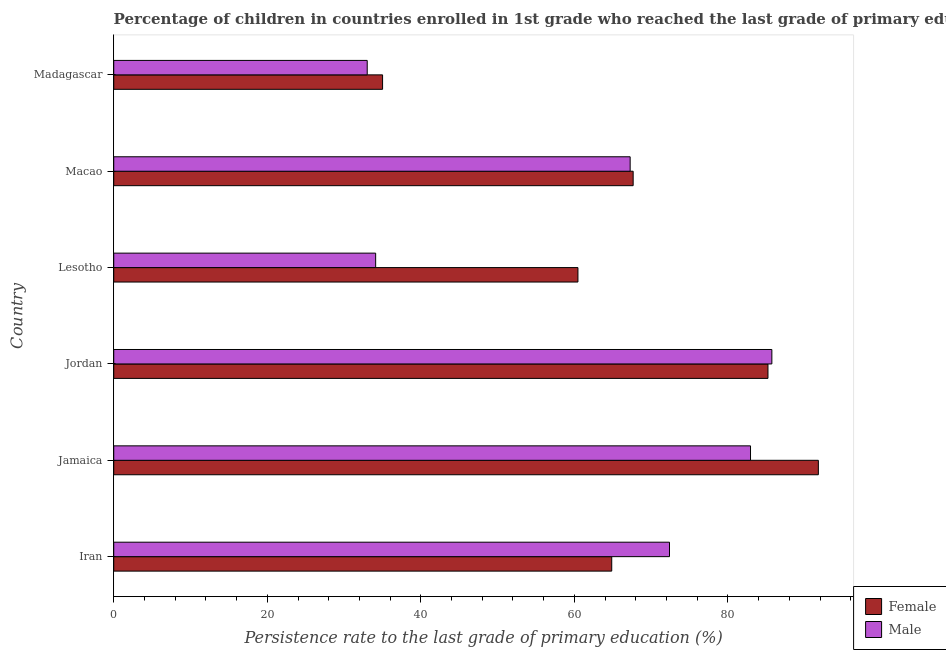Are the number of bars per tick equal to the number of legend labels?
Provide a short and direct response. Yes. How many bars are there on the 4th tick from the top?
Your response must be concise. 2. How many bars are there on the 3rd tick from the bottom?
Give a very brief answer. 2. What is the label of the 1st group of bars from the top?
Ensure brevity in your answer.  Madagascar. What is the persistence rate of female students in Jamaica?
Ensure brevity in your answer.  91.78. Across all countries, what is the maximum persistence rate of male students?
Provide a short and direct response. 85.72. Across all countries, what is the minimum persistence rate of male students?
Offer a terse response. 33.02. In which country was the persistence rate of female students maximum?
Ensure brevity in your answer.  Jamaica. In which country was the persistence rate of male students minimum?
Provide a succinct answer. Madagascar. What is the total persistence rate of female students in the graph?
Make the answer very short. 405. What is the difference between the persistence rate of male students in Iran and that in Madagascar?
Give a very brief answer. 39.37. What is the difference between the persistence rate of male students in Jamaica and the persistence rate of female students in Madagascar?
Your response must be concise. 47.93. What is the average persistence rate of male students per country?
Provide a short and direct response. 62.58. What is the difference between the persistence rate of male students and persistence rate of female students in Iran?
Your response must be concise. 7.52. Is the persistence rate of female students in Jordan less than that in Lesotho?
Make the answer very short. No. Is the difference between the persistence rate of male students in Iran and Macao greater than the difference between the persistence rate of female students in Iran and Macao?
Your response must be concise. Yes. What is the difference between the highest and the second highest persistence rate of male students?
Your answer should be very brief. 2.78. What is the difference between the highest and the lowest persistence rate of female students?
Ensure brevity in your answer.  56.76. What does the 1st bar from the bottom in Madagascar represents?
Make the answer very short. Female. Are all the bars in the graph horizontal?
Give a very brief answer. Yes. Does the graph contain grids?
Make the answer very short. No. Where does the legend appear in the graph?
Your answer should be very brief. Bottom right. How many legend labels are there?
Provide a succinct answer. 2. What is the title of the graph?
Offer a very short reply. Percentage of children in countries enrolled in 1st grade who reached the last grade of primary education. Does "Transport services" appear as one of the legend labels in the graph?
Your answer should be compact. No. What is the label or title of the X-axis?
Keep it short and to the point. Persistence rate to the last grade of primary education (%). What is the label or title of the Y-axis?
Make the answer very short. Country. What is the Persistence rate to the last grade of primary education (%) in Female in Iran?
Provide a short and direct response. 64.87. What is the Persistence rate to the last grade of primary education (%) of Male in Iran?
Provide a short and direct response. 72.39. What is the Persistence rate to the last grade of primary education (%) in Female in Jamaica?
Provide a short and direct response. 91.78. What is the Persistence rate to the last grade of primary education (%) in Male in Jamaica?
Offer a very short reply. 82.94. What is the Persistence rate to the last grade of primary education (%) in Female in Jordan?
Provide a succinct answer. 85.22. What is the Persistence rate to the last grade of primary education (%) of Male in Jordan?
Offer a terse response. 85.72. What is the Persistence rate to the last grade of primary education (%) in Female in Lesotho?
Keep it short and to the point. 60.46. What is the Persistence rate to the last grade of primary education (%) of Male in Lesotho?
Ensure brevity in your answer.  34.12. What is the Persistence rate to the last grade of primary education (%) of Female in Macao?
Provide a succinct answer. 67.66. What is the Persistence rate to the last grade of primary education (%) in Male in Macao?
Your answer should be compact. 67.27. What is the Persistence rate to the last grade of primary education (%) of Female in Madagascar?
Your response must be concise. 35.02. What is the Persistence rate to the last grade of primary education (%) in Male in Madagascar?
Ensure brevity in your answer.  33.02. Across all countries, what is the maximum Persistence rate to the last grade of primary education (%) of Female?
Give a very brief answer. 91.78. Across all countries, what is the maximum Persistence rate to the last grade of primary education (%) in Male?
Provide a succinct answer. 85.72. Across all countries, what is the minimum Persistence rate to the last grade of primary education (%) of Female?
Provide a succinct answer. 35.02. Across all countries, what is the minimum Persistence rate to the last grade of primary education (%) in Male?
Provide a short and direct response. 33.02. What is the total Persistence rate to the last grade of primary education (%) of Female in the graph?
Give a very brief answer. 405. What is the total Persistence rate to the last grade of primary education (%) of Male in the graph?
Provide a succinct answer. 375.45. What is the difference between the Persistence rate to the last grade of primary education (%) in Female in Iran and that in Jamaica?
Ensure brevity in your answer.  -26.91. What is the difference between the Persistence rate to the last grade of primary education (%) of Male in Iran and that in Jamaica?
Your answer should be very brief. -10.55. What is the difference between the Persistence rate to the last grade of primary education (%) of Female in Iran and that in Jordan?
Your response must be concise. -20.35. What is the difference between the Persistence rate to the last grade of primary education (%) in Male in Iran and that in Jordan?
Ensure brevity in your answer.  -13.33. What is the difference between the Persistence rate to the last grade of primary education (%) in Female in Iran and that in Lesotho?
Your response must be concise. 4.4. What is the difference between the Persistence rate to the last grade of primary education (%) in Male in Iran and that in Lesotho?
Ensure brevity in your answer.  38.27. What is the difference between the Persistence rate to the last grade of primary education (%) of Female in Iran and that in Macao?
Offer a terse response. -2.79. What is the difference between the Persistence rate to the last grade of primary education (%) in Male in Iran and that in Macao?
Make the answer very short. 5.12. What is the difference between the Persistence rate to the last grade of primary education (%) of Female in Iran and that in Madagascar?
Your response must be concise. 29.85. What is the difference between the Persistence rate to the last grade of primary education (%) in Male in Iran and that in Madagascar?
Your answer should be very brief. 39.37. What is the difference between the Persistence rate to the last grade of primary education (%) of Female in Jamaica and that in Jordan?
Offer a very short reply. 6.56. What is the difference between the Persistence rate to the last grade of primary education (%) of Male in Jamaica and that in Jordan?
Offer a terse response. -2.78. What is the difference between the Persistence rate to the last grade of primary education (%) of Female in Jamaica and that in Lesotho?
Your answer should be compact. 31.31. What is the difference between the Persistence rate to the last grade of primary education (%) in Male in Jamaica and that in Lesotho?
Give a very brief answer. 48.83. What is the difference between the Persistence rate to the last grade of primary education (%) in Female in Jamaica and that in Macao?
Offer a terse response. 24.12. What is the difference between the Persistence rate to the last grade of primary education (%) in Male in Jamaica and that in Macao?
Keep it short and to the point. 15.68. What is the difference between the Persistence rate to the last grade of primary education (%) in Female in Jamaica and that in Madagascar?
Give a very brief answer. 56.76. What is the difference between the Persistence rate to the last grade of primary education (%) in Male in Jamaica and that in Madagascar?
Offer a very short reply. 49.93. What is the difference between the Persistence rate to the last grade of primary education (%) in Female in Jordan and that in Lesotho?
Provide a succinct answer. 24.75. What is the difference between the Persistence rate to the last grade of primary education (%) of Male in Jordan and that in Lesotho?
Provide a succinct answer. 51.61. What is the difference between the Persistence rate to the last grade of primary education (%) of Female in Jordan and that in Macao?
Your answer should be very brief. 17.56. What is the difference between the Persistence rate to the last grade of primary education (%) of Male in Jordan and that in Macao?
Ensure brevity in your answer.  18.46. What is the difference between the Persistence rate to the last grade of primary education (%) of Female in Jordan and that in Madagascar?
Make the answer very short. 50.2. What is the difference between the Persistence rate to the last grade of primary education (%) in Male in Jordan and that in Madagascar?
Ensure brevity in your answer.  52.71. What is the difference between the Persistence rate to the last grade of primary education (%) in Female in Lesotho and that in Macao?
Provide a succinct answer. -7.19. What is the difference between the Persistence rate to the last grade of primary education (%) of Male in Lesotho and that in Macao?
Ensure brevity in your answer.  -33.15. What is the difference between the Persistence rate to the last grade of primary education (%) in Female in Lesotho and that in Madagascar?
Your answer should be compact. 25.45. What is the difference between the Persistence rate to the last grade of primary education (%) in Male in Lesotho and that in Madagascar?
Make the answer very short. 1.1. What is the difference between the Persistence rate to the last grade of primary education (%) of Female in Macao and that in Madagascar?
Provide a short and direct response. 32.64. What is the difference between the Persistence rate to the last grade of primary education (%) of Male in Macao and that in Madagascar?
Provide a succinct answer. 34.25. What is the difference between the Persistence rate to the last grade of primary education (%) in Female in Iran and the Persistence rate to the last grade of primary education (%) in Male in Jamaica?
Offer a terse response. -18.08. What is the difference between the Persistence rate to the last grade of primary education (%) in Female in Iran and the Persistence rate to the last grade of primary education (%) in Male in Jordan?
Your answer should be compact. -20.86. What is the difference between the Persistence rate to the last grade of primary education (%) in Female in Iran and the Persistence rate to the last grade of primary education (%) in Male in Lesotho?
Provide a short and direct response. 30.75. What is the difference between the Persistence rate to the last grade of primary education (%) of Female in Iran and the Persistence rate to the last grade of primary education (%) of Male in Macao?
Provide a short and direct response. -2.4. What is the difference between the Persistence rate to the last grade of primary education (%) in Female in Iran and the Persistence rate to the last grade of primary education (%) in Male in Madagascar?
Provide a short and direct response. 31.85. What is the difference between the Persistence rate to the last grade of primary education (%) of Female in Jamaica and the Persistence rate to the last grade of primary education (%) of Male in Jordan?
Your answer should be very brief. 6.06. What is the difference between the Persistence rate to the last grade of primary education (%) of Female in Jamaica and the Persistence rate to the last grade of primary education (%) of Male in Lesotho?
Make the answer very short. 57.66. What is the difference between the Persistence rate to the last grade of primary education (%) in Female in Jamaica and the Persistence rate to the last grade of primary education (%) in Male in Macao?
Give a very brief answer. 24.51. What is the difference between the Persistence rate to the last grade of primary education (%) in Female in Jamaica and the Persistence rate to the last grade of primary education (%) in Male in Madagascar?
Provide a succinct answer. 58.76. What is the difference between the Persistence rate to the last grade of primary education (%) in Female in Jordan and the Persistence rate to the last grade of primary education (%) in Male in Lesotho?
Offer a very short reply. 51.1. What is the difference between the Persistence rate to the last grade of primary education (%) of Female in Jordan and the Persistence rate to the last grade of primary education (%) of Male in Macao?
Ensure brevity in your answer.  17.95. What is the difference between the Persistence rate to the last grade of primary education (%) of Female in Jordan and the Persistence rate to the last grade of primary education (%) of Male in Madagascar?
Offer a very short reply. 52.2. What is the difference between the Persistence rate to the last grade of primary education (%) of Female in Lesotho and the Persistence rate to the last grade of primary education (%) of Male in Macao?
Provide a short and direct response. -6.8. What is the difference between the Persistence rate to the last grade of primary education (%) in Female in Lesotho and the Persistence rate to the last grade of primary education (%) in Male in Madagascar?
Your response must be concise. 27.45. What is the difference between the Persistence rate to the last grade of primary education (%) in Female in Macao and the Persistence rate to the last grade of primary education (%) in Male in Madagascar?
Provide a short and direct response. 34.64. What is the average Persistence rate to the last grade of primary education (%) in Female per country?
Offer a very short reply. 67.5. What is the average Persistence rate to the last grade of primary education (%) in Male per country?
Keep it short and to the point. 62.58. What is the difference between the Persistence rate to the last grade of primary education (%) in Female and Persistence rate to the last grade of primary education (%) in Male in Iran?
Provide a succinct answer. -7.52. What is the difference between the Persistence rate to the last grade of primary education (%) of Female and Persistence rate to the last grade of primary education (%) of Male in Jamaica?
Offer a very short reply. 8.84. What is the difference between the Persistence rate to the last grade of primary education (%) of Female and Persistence rate to the last grade of primary education (%) of Male in Jordan?
Ensure brevity in your answer.  -0.51. What is the difference between the Persistence rate to the last grade of primary education (%) of Female and Persistence rate to the last grade of primary education (%) of Male in Lesotho?
Keep it short and to the point. 26.35. What is the difference between the Persistence rate to the last grade of primary education (%) of Female and Persistence rate to the last grade of primary education (%) of Male in Macao?
Provide a succinct answer. 0.39. What is the ratio of the Persistence rate to the last grade of primary education (%) in Female in Iran to that in Jamaica?
Give a very brief answer. 0.71. What is the ratio of the Persistence rate to the last grade of primary education (%) of Male in Iran to that in Jamaica?
Provide a short and direct response. 0.87. What is the ratio of the Persistence rate to the last grade of primary education (%) of Female in Iran to that in Jordan?
Offer a terse response. 0.76. What is the ratio of the Persistence rate to the last grade of primary education (%) of Male in Iran to that in Jordan?
Give a very brief answer. 0.84. What is the ratio of the Persistence rate to the last grade of primary education (%) in Female in Iran to that in Lesotho?
Offer a very short reply. 1.07. What is the ratio of the Persistence rate to the last grade of primary education (%) of Male in Iran to that in Lesotho?
Give a very brief answer. 2.12. What is the ratio of the Persistence rate to the last grade of primary education (%) of Female in Iran to that in Macao?
Ensure brevity in your answer.  0.96. What is the ratio of the Persistence rate to the last grade of primary education (%) of Male in Iran to that in Macao?
Your response must be concise. 1.08. What is the ratio of the Persistence rate to the last grade of primary education (%) of Female in Iran to that in Madagascar?
Make the answer very short. 1.85. What is the ratio of the Persistence rate to the last grade of primary education (%) in Male in Iran to that in Madagascar?
Offer a terse response. 2.19. What is the ratio of the Persistence rate to the last grade of primary education (%) of Female in Jamaica to that in Jordan?
Your response must be concise. 1.08. What is the ratio of the Persistence rate to the last grade of primary education (%) in Male in Jamaica to that in Jordan?
Provide a succinct answer. 0.97. What is the ratio of the Persistence rate to the last grade of primary education (%) in Female in Jamaica to that in Lesotho?
Keep it short and to the point. 1.52. What is the ratio of the Persistence rate to the last grade of primary education (%) in Male in Jamaica to that in Lesotho?
Ensure brevity in your answer.  2.43. What is the ratio of the Persistence rate to the last grade of primary education (%) in Female in Jamaica to that in Macao?
Provide a short and direct response. 1.36. What is the ratio of the Persistence rate to the last grade of primary education (%) in Male in Jamaica to that in Macao?
Give a very brief answer. 1.23. What is the ratio of the Persistence rate to the last grade of primary education (%) in Female in Jamaica to that in Madagascar?
Give a very brief answer. 2.62. What is the ratio of the Persistence rate to the last grade of primary education (%) of Male in Jamaica to that in Madagascar?
Offer a terse response. 2.51. What is the ratio of the Persistence rate to the last grade of primary education (%) in Female in Jordan to that in Lesotho?
Provide a succinct answer. 1.41. What is the ratio of the Persistence rate to the last grade of primary education (%) of Male in Jordan to that in Lesotho?
Give a very brief answer. 2.51. What is the ratio of the Persistence rate to the last grade of primary education (%) in Female in Jordan to that in Macao?
Your answer should be compact. 1.26. What is the ratio of the Persistence rate to the last grade of primary education (%) of Male in Jordan to that in Macao?
Give a very brief answer. 1.27. What is the ratio of the Persistence rate to the last grade of primary education (%) in Female in Jordan to that in Madagascar?
Give a very brief answer. 2.43. What is the ratio of the Persistence rate to the last grade of primary education (%) of Male in Jordan to that in Madagascar?
Offer a terse response. 2.6. What is the ratio of the Persistence rate to the last grade of primary education (%) in Female in Lesotho to that in Macao?
Provide a short and direct response. 0.89. What is the ratio of the Persistence rate to the last grade of primary education (%) in Male in Lesotho to that in Macao?
Offer a terse response. 0.51. What is the ratio of the Persistence rate to the last grade of primary education (%) of Female in Lesotho to that in Madagascar?
Provide a succinct answer. 1.73. What is the ratio of the Persistence rate to the last grade of primary education (%) of Female in Macao to that in Madagascar?
Make the answer very short. 1.93. What is the ratio of the Persistence rate to the last grade of primary education (%) in Male in Macao to that in Madagascar?
Your answer should be compact. 2.04. What is the difference between the highest and the second highest Persistence rate to the last grade of primary education (%) in Female?
Your response must be concise. 6.56. What is the difference between the highest and the second highest Persistence rate to the last grade of primary education (%) of Male?
Offer a very short reply. 2.78. What is the difference between the highest and the lowest Persistence rate to the last grade of primary education (%) in Female?
Provide a succinct answer. 56.76. What is the difference between the highest and the lowest Persistence rate to the last grade of primary education (%) of Male?
Provide a short and direct response. 52.71. 